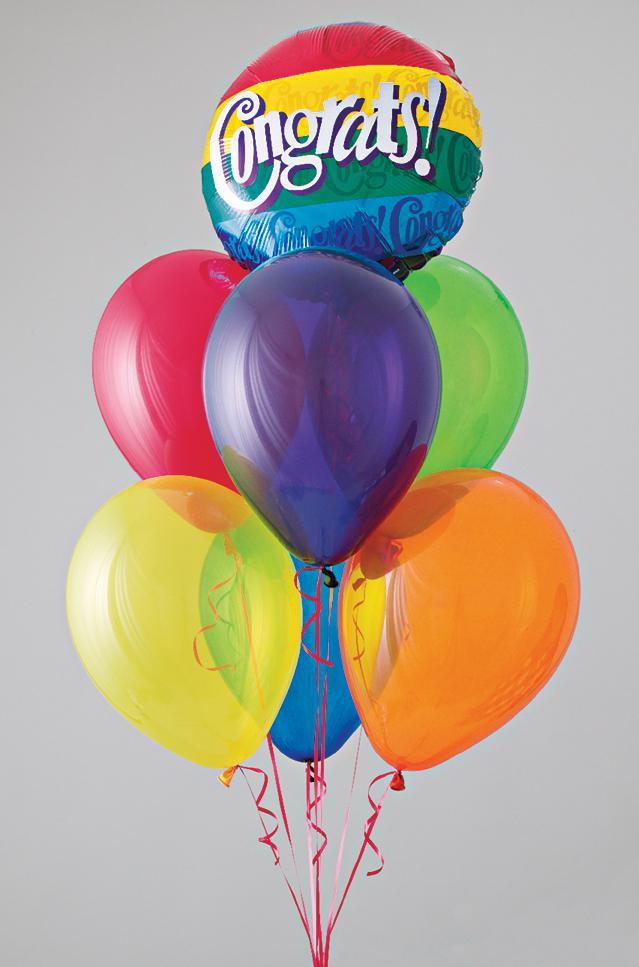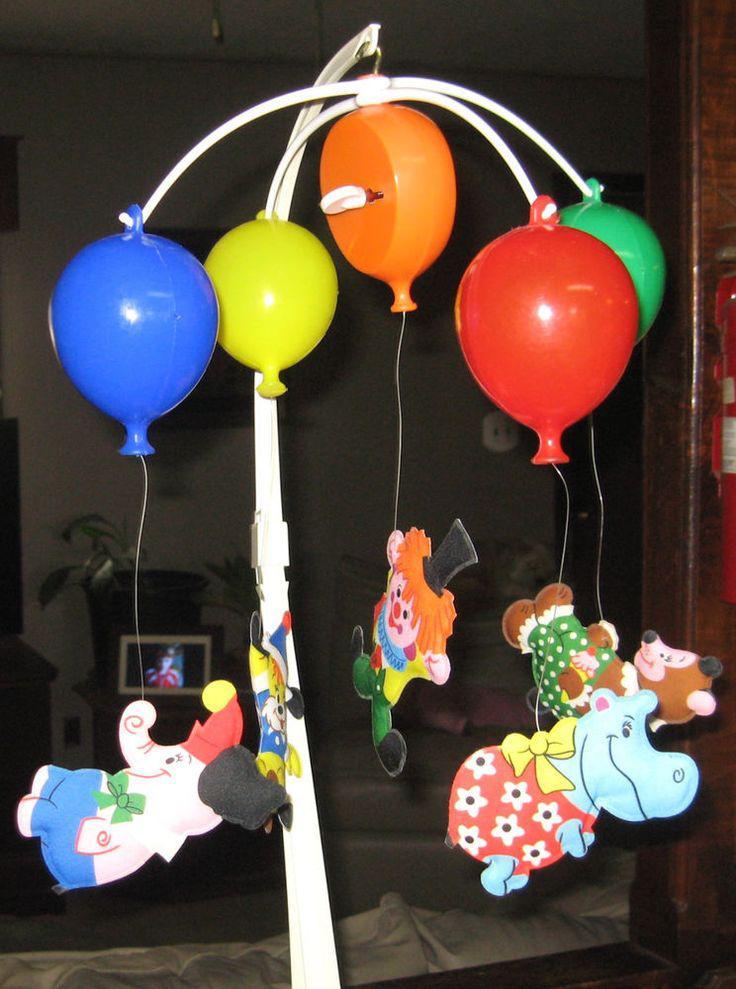The first image is the image on the left, the second image is the image on the right. Considering the images on both sides, is "One of the images shows a clown wearing a hat." valid? Answer yes or no. Yes. 